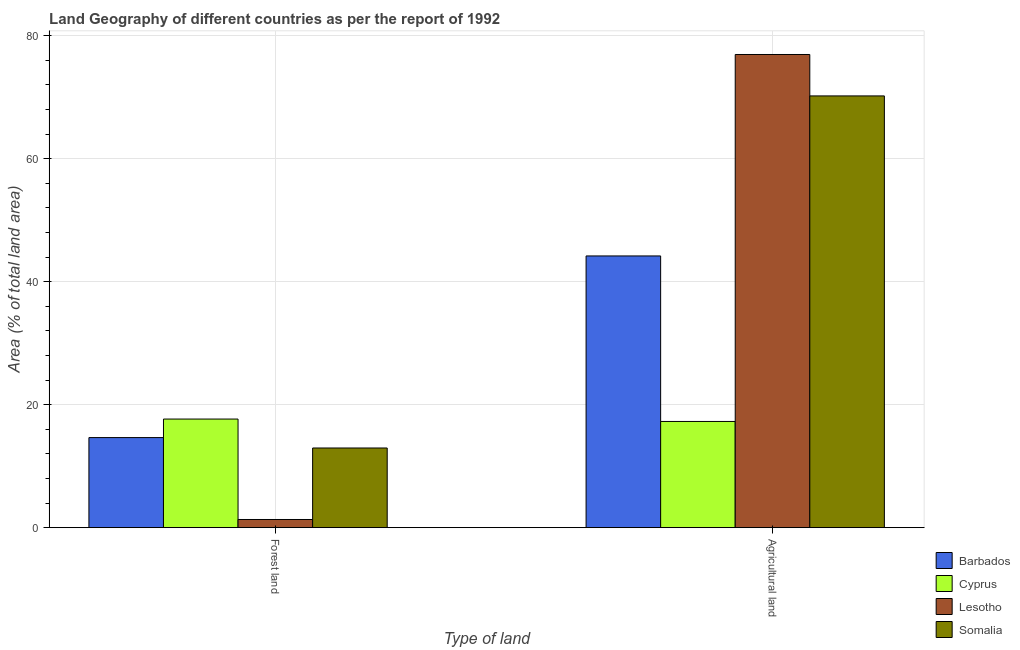Are the number of bars per tick equal to the number of legend labels?
Ensure brevity in your answer.  Yes. Are the number of bars on each tick of the X-axis equal?
Your answer should be very brief. Yes. What is the label of the 1st group of bars from the left?
Keep it short and to the point. Forest land. What is the percentage of land area under forests in Somalia?
Provide a succinct answer. 12.96. Across all countries, what is the maximum percentage of land area under agriculture?
Offer a terse response. 76.94. Across all countries, what is the minimum percentage of land area under forests?
Provide a succinct answer. 1.33. In which country was the percentage of land area under agriculture maximum?
Offer a terse response. Lesotho. In which country was the percentage of land area under forests minimum?
Give a very brief answer. Lesotho. What is the total percentage of land area under forests in the graph?
Provide a short and direct response. 46.6. What is the difference between the percentage of land area under agriculture in Lesotho and that in Cyprus?
Offer a very short reply. 59.67. What is the difference between the percentage of land area under agriculture in Somalia and the percentage of land area under forests in Barbados?
Your answer should be compact. 55.55. What is the average percentage of land area under agriculture per country?
Keep it short and to the point. 52.15. What is the difference between the percentage of land area under agriculture and percentage of land area under forests in Somalia?
Your answer should be compact. 57.25. What is the ratio of the percentage of land area under agriculture in Lesotho to that in Somalia?
Offer a terse response. 1.1. In how many countries, is the percentage of land area under forests greater than the average percentage of land area under forests taken over all countries?
Your response must be concise. 3. What does the 2nd bar from the left in Forest land represents?
Your answer should be very brief. Cyprus. What does the 4th bar from the right in Agricultural land represents?
Your response must be concise. Barbados. How many bars are there?
Offer a very short reply. 8. How many countries are there in the graph?
Keep it short and to the point. 4. What is the difference between two consecutive major ticks on the Y-axis?
Offer a terse response. 20. Are the values on the major ticks of Y-axis written in scientific E-notation?
Your answer should be compact. No. Does the graph contain any zero values?
Ensure brevity in your answer.  No. Does the graph contain grids?
Provide a short and direct response. Yes. Where does the legend appear in the graph?
Ensure brevity in your answer.  Bottom right. How many legend labels are there?
Your answer should be very brief. 4. What is the title of the graph?
Provide a succinct answer. Land Geography of different countries as per the report of 1992. What is the label or title of the X-axis?
Your response must be concise. Type of land. What is the label or title of the Y-axis?
Your answer should be very brief. Area (% of total land area). What is the Area (% of total land area) of Barbados in Forest land?
Keep it short and to the point. 14.65. What is the Area (% of total land area) in Cyprus in Forest land?
Offer a terse response. 17.66. What is the Area (% of total land area) of Lesotho in Forest land?
Your answer should be very brief. 1.33. What is the Area (% of total land area) in Somalia in Forest land?
Your response must be concise. 12.96. What is the Area (% of total land area) in Barbados in Agricultural land?
Your answer should be very brief. 44.19. What is the Area (% of total land area) in Cyprus in Agricultural land?
Offer a very short reply. 17.27. What is the Area (% of total land area) in Lesotho in Agricultural land?
Your answer should be very brief. 76.94. What is the Area (% of total land area) in Somalia in Agricultural land?
Ensure brevity in your answer.  70.21. Across all Type of land, what is the maximum Area (% of total land area) of Barbados?
Your response must be concise. 44.19. Across all Type of land, what is the maximum Area (% of total land area) of Cyprus?
Your answer should be compact. 17.66. Across all Type of land, what is the maximum Area (% of total land area) in Lesotho?
Offer a terse response. 76.94. Across all Type of land, what is the maximum Area (% of total land area) of Somalia?
Make the answer very short. 70.21. Across all Type of land, what is the minimum Area (% of total land area) in Barbados?
Your answer should be very brief. 14.65. Across all Type of land, what is the minimum Area (% of total land area) in Cyprus?
Give a very brief answer. 17.27. Across all Type of land, what is the minimum Area (% of total land area) of Lesotho?
Give a very brief answer. 1.33. Across all Type of land, what is the minimum Area (% of total land area) in Somalia?
Provide a short and direct response. 12.96. What is the total Area (% of total land area) of Barbados in the graph?
Ensure brevity in your answer.  58.84. What is the total Area (% of total land area) in Cyprus in the graph?
Your answer should be very brief. 34.94. What is the total Area (% of total land area) in Lesotho in the graph?
Your response must be concise. 78.27. What is the total Area (% of total land area) of Somalia in the graph?
Offer a terse response. 83.16. What is the difference between the Area (% of total land area) of Barbados in Forest land and that in Agricultural land?
Make the answer very short. -29.53. What is the difference between the Area (% of total land area) in Cyprus in Forest land and that in Agricultural land?
Keep it short and to the point. 0.39. What is the difference between the Area (% of total land area) in Lesotho in Forest land and that in Agricultural land?
Offer a very short reply. -75.61. What is the difference between the Area (% of total land area) in Somalia in Forest land and that in Agricultural land?
Provide a succinct answer. -57.25. What is the difference between the Area (% of total land area) in Barbados in Forest land and the Area (% of total land area) in Cyprus in Agricultural land?
Make the answer very short. -2.62. What is the difference between the Area (% of total land area) of Barbados in Forest land and the Area (% of total land area) of Lesotho in Agricultural land?
Make the answer very short. -62.29. What is the difference between the Area (% of total land area) of Barbados in Forest land and the Area (% of total land area) of Somalia in Agricultural land?
Offer a terse response. -55.55. What is the difference between the Area (% of total land area) of Cyprus in Forest land and the Area (% of total land area) of Lesotho in Agricultural land?
Your answer should be compact. -59.28. What is the difference between the Area (% of total land area) of Cyprus in Forest land and the Area (% of total land area) of Somalia in Agricultural land?
Provide a succinct answer. -52.54. What is the difference between the Area (% of total land area) of Lesotho in Forest land and the Area (% of total land area) of Somalia in Agricultural land?
Make the answer very short. -68.88. What is the average Area (% of total land area) of Barbados per Type of land?
Give a very brief answer. 29.42. What is the average Area (% of total land area) in Cyprus per Type of land?
Provide a succinct answer. 17.47. What is the average Area (% of total land area) of Lesotho per Type of land?
Offer a terse response. 39.14. What is the average Area (% of total land area) in Somalia per Type of land?
Your answer should be compact. 41.58. What is the difference between the Area (% of total land area) of Barbados and Area (% of total land area) of Cyprus in Forest land?
Ensure brevity in your answer.  -3.01. What is the difference between the Area (% of total land area) of Barbados and Area (% of total land area) of Lesotho in Forest land?
Your answer should be compact. 13.32. What is the difference between the Area (% of total land area) of Barbados and Area (% of total land area) of Somalia in Forest land?
Your answer should be very brief. 1.69. What is the difference between the Area (% of total land area) of Cyprus and Area (% of total land area) of Lesotho in Forest land?
Your response must be concise. 16.33. What is the difference between the Area (% of total land area) of Cyprus and Area (% of total land area) of Somalia in Forest land?
Your answer should be compact. 4.71. What is the difference between the Area (% of total land area) of Lesotho and Area (% of total land area) of Somalia in Forest land?
Your response must be concise. -11.63. What is the difference between the Area (% of total land area) in Barbados and Area (% of total land area) in Cyprus in Agricultural land?
Make the answer very short. 26.91. What is the difference between the Area (% of total land area) of Barbados and Area (% of total land area) of Lesotho in Agricultural land?
Keep it short and to the point. -32.76. What is the difference between the Area (% of total land area) in Barbados and Area (% of total land area) in Somalia in Agricultural land?
Your answer should be very brief. -26.02. What is the difference between the Area (% of total land area) of Cyprus and Area (% of total land area) of Lesotho in Agricultural land?
Your answer should be compact. -59.67. What is the difference between the Area (% of total land area) in Cyprus and Area (% of total land area) in Somalia in Agricultural land?
Provide a short and direct response. -52.93. What is the difference between the Area (% of total land area) of Lesotho and Area (% of total land area) of Somalia in Agricultural land?
Provide a short and direct response. 6.74. What is the ratio of the Area (% of total land area) of Barbados in Forest land to that in Agricultural land?
Provide a short and direct response. 0.33. What is the ratio of the Area (% of total land area) of Cyprus in Forest land to that in Agricultural land?
Your answer should be very brief. 1.02. What is the ratio of the Area (% of total land area) of Lesotho in Forest land to that in Agricultural land?
Provide a short and direct response. 0.02. What is the ratio of the Area (% of total land area) of Somalia in Forest land to that in Agricultural land?
Your response must be concise. 0.18. What is the difference between the highest and the second highest Area (% of total land area) in Barbados?
Make the answer very short. 29.53. What is the difference between the highest and the second highest Area (% of total land area) of Cyprus?
Offer a very short reply. 0.39. What is the difference between the highest and the second highest Area (% of total land area) of Lesotho?
Your answer should be very brief. 75.61. What is the difference between the highest and the second highest Area (% of total land area) in Somalia?
Offer a terse response. 57.25. What is the difference between the highest and the lowest Area (% of total land area) of Barbados?
Provide a succinct answer. 29.53. What is the difference between the highest and the lowest Area (% of total land area) of Cyprus?
Keep it short and to the point. 0.39. What is the difference between the highest and the lowest Area (% of total land area) of Lesotho?
Your answer should be compact. 75.61. What is the difference between the highest and the lowest Area (% of total land area) in Somalia?
Offer a terse response. 57.25. 